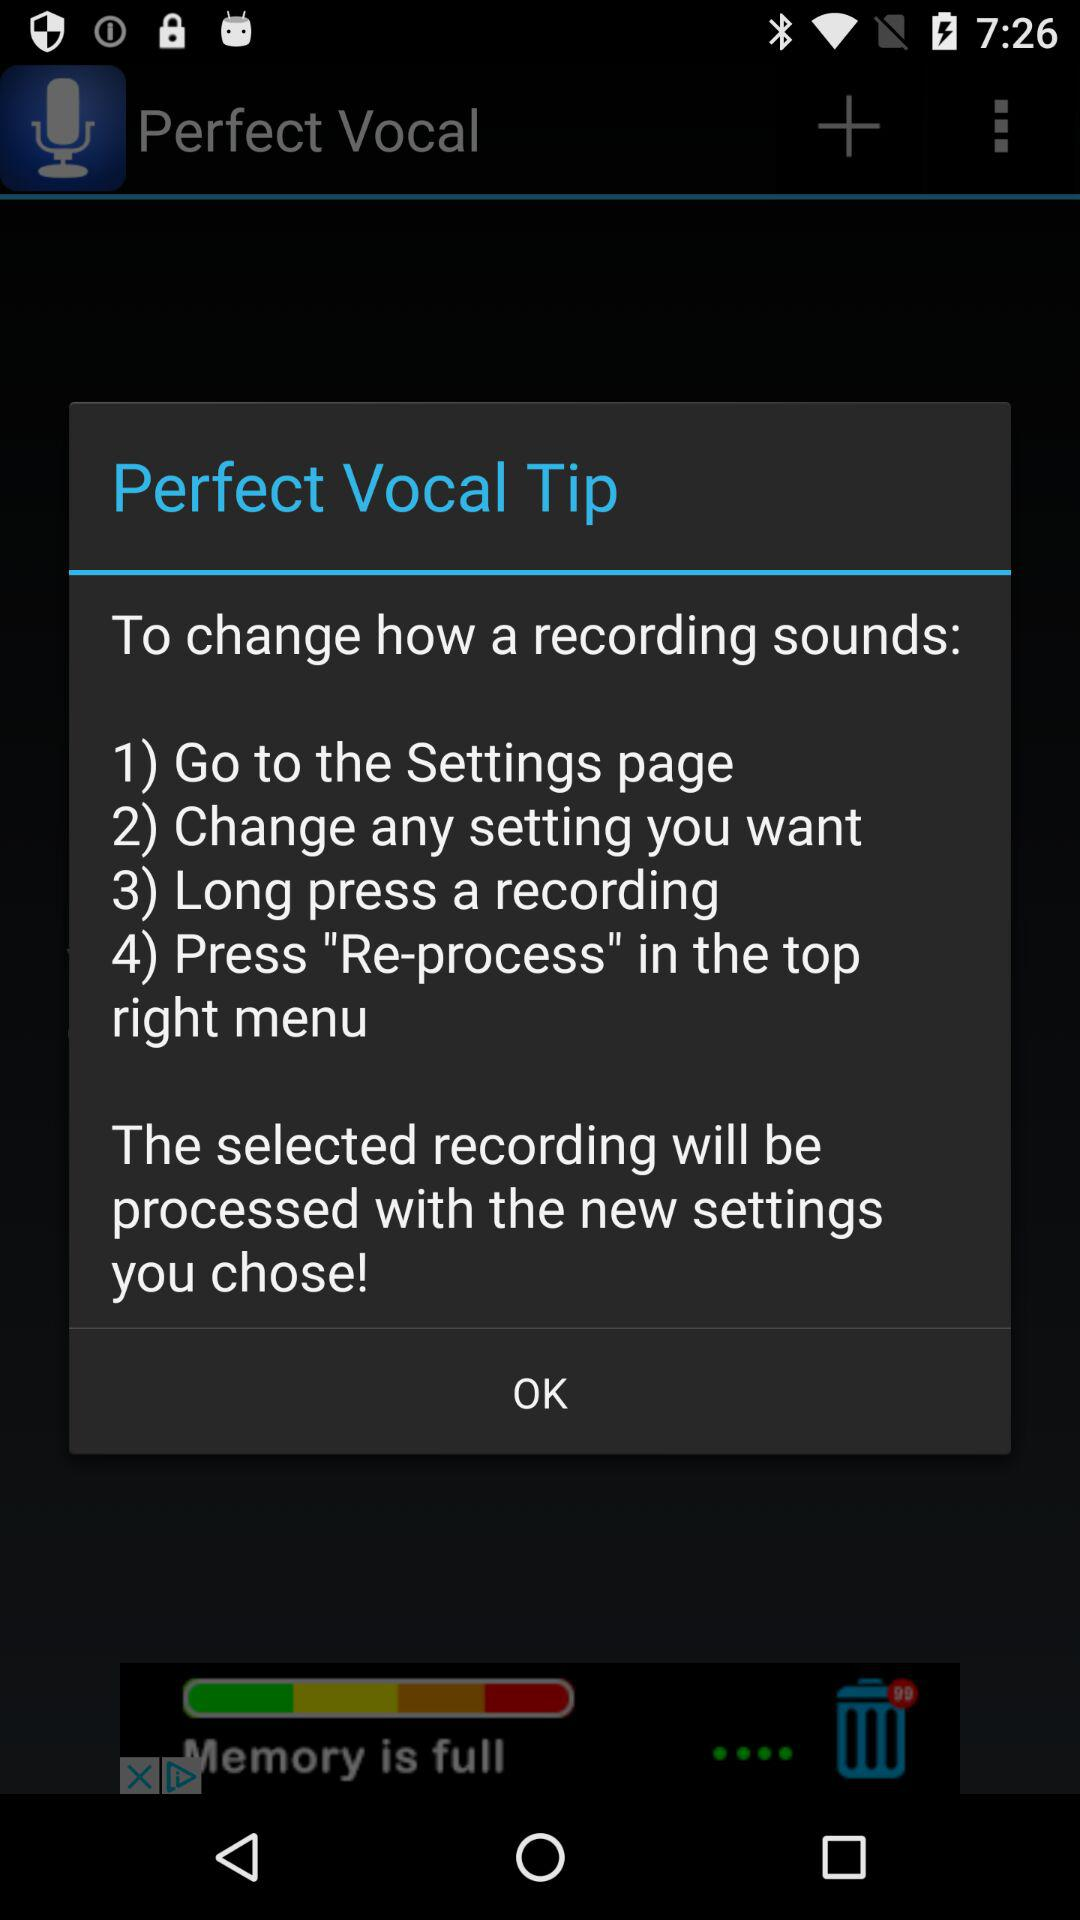How many recordings are there?
When the provided information is insufficient, respond with <no answer>. <no answer> 